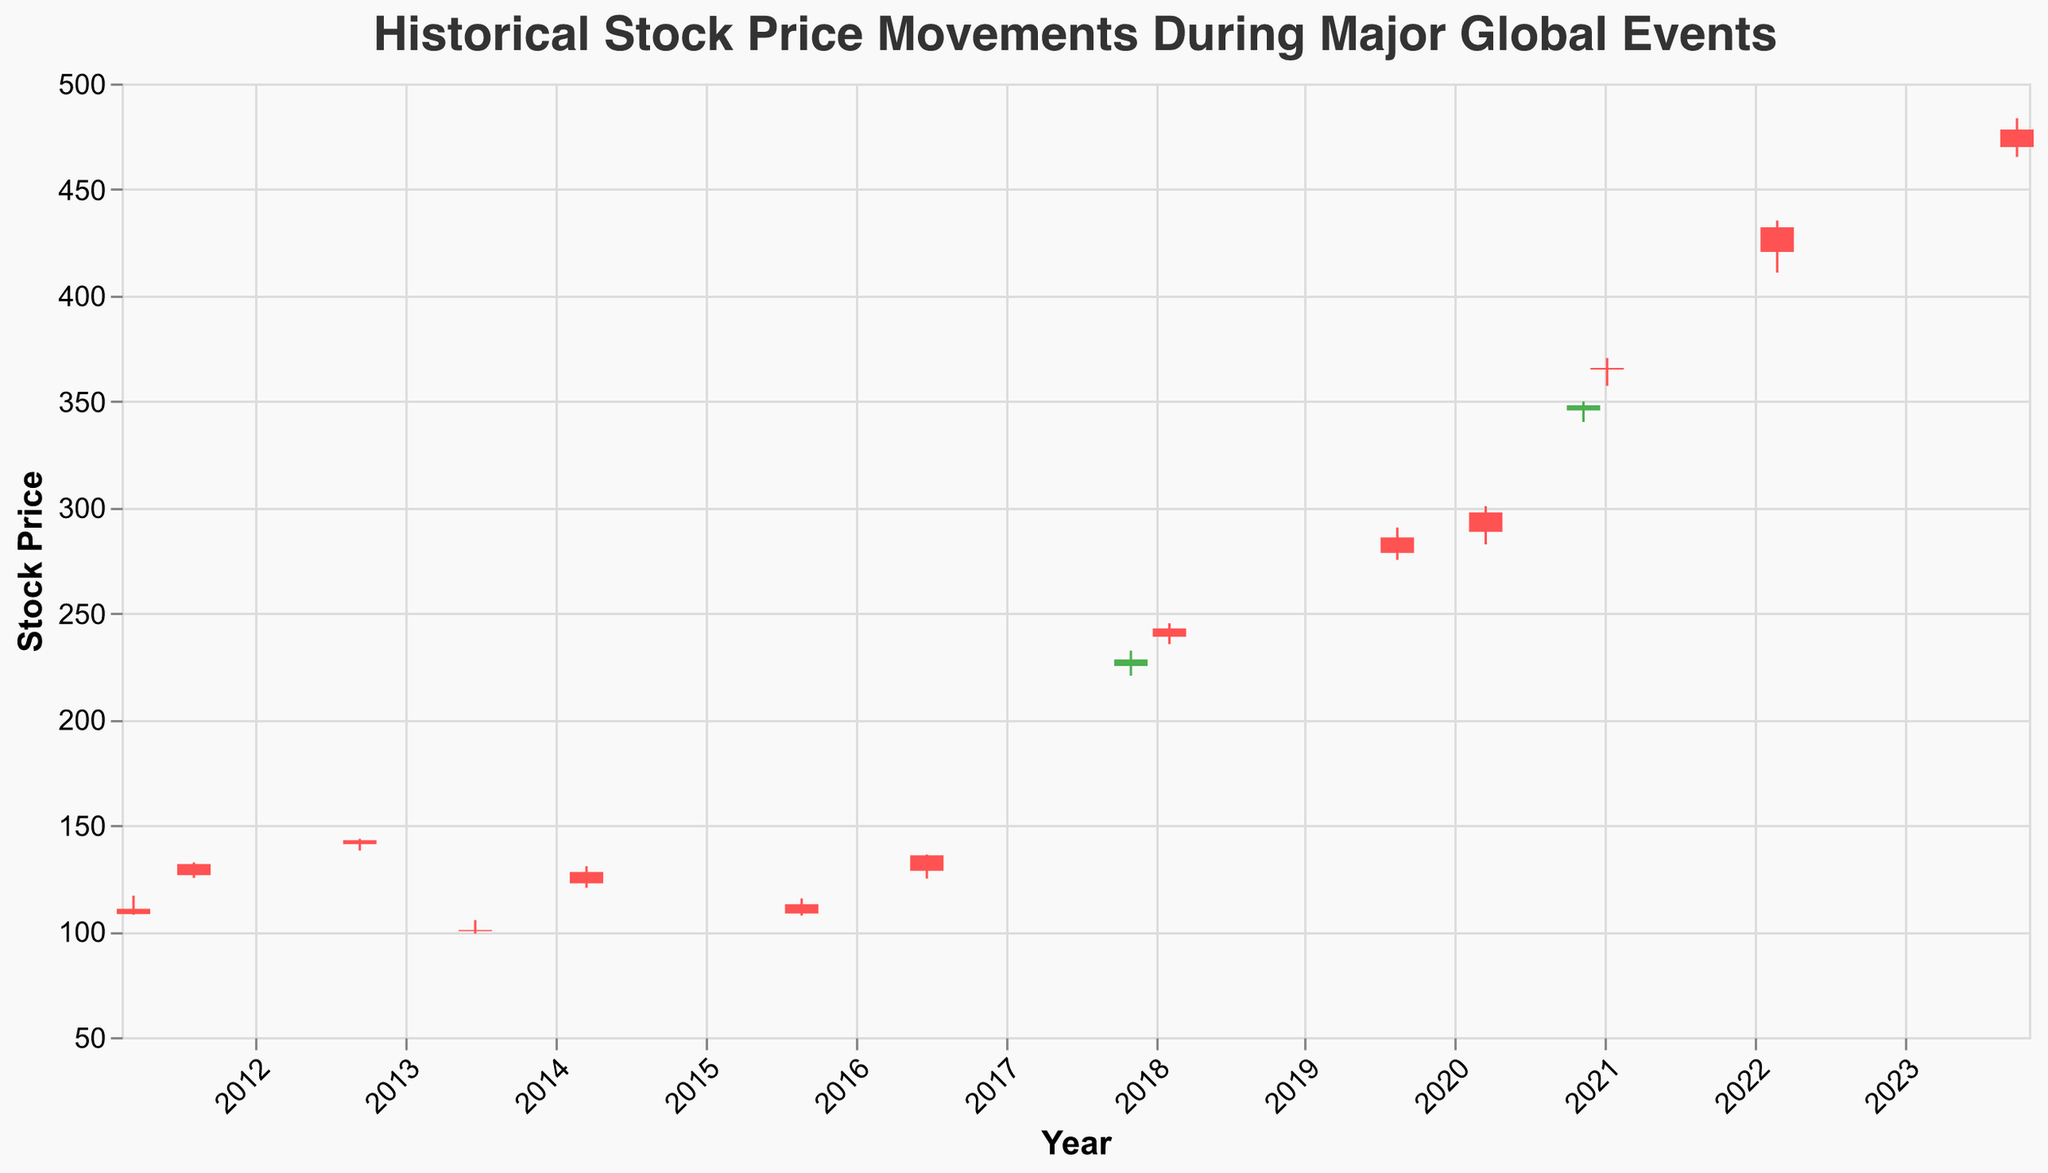Which event corresponds to the highest stock price close? Locate the highest closing stock price in the plot, which is $420.50 on 2022-02-24 during the Russian Invasion of Ukraine.
Answer: Russian Invasion of Ukraine What was the stock price range during the COVID-19 Pandemic Declared event? Identify the lowest and highest prices for this event: $282.50 (Low) and $300.52 (High).
Answer: $282.50 - $300.52 How much did the stock price change from open to close during the Brexit Referendum? Subtract the closing price ($128.45) from the opening price ($135.78).
Answer: -$7.33 Did the stock price close higher or lower than it opened during the US Debt Ceiling Crisis? Check if the closing price ($126.45) is greater than the opening price ($131.62).
Answer: Lower Which event had the highest trading volume? Identify the highest volume value in the plot, which is 8,000,000 during the COVID-19 Pandemic Declared event.
Answer: COVID-19 Pandemic Declared What's the average closing price of all the events? Sum all the closing prices and divide by the number of events. (108.02+126.45+141.00+99.99+122.53+108.30+128.45+228.20+238.89+278.50+288.45+348.10+365.00+420.50+470.02) / 15 = 226.75
Answer: 226.75 Compare the stock price change between the US Tax Reform and the 2018 Stock Market Correction events. Which had a larger drop? Calculate the difference for both events: US Tax Reform (225.15 to 228.20) and 2018 Stock Market Correction (242.85 to 238.89). The 2018 Stock Market Correction had a larger drop of -3.96 compared to the US Tax Reform’s +3.05.
Answer: 2018 Stock Market Correction What is the median closing stock price among the plotted events? Sort all closing prices and find the middle value. (99.99, 108.02, 108.30, 122.53, 126.45, 128.45, 141.00, 228.20, 238.89, 278.50, 288.45, 348.10, 365.00, 420.50, 470.02) The median value is 228.20.
Answer: 228.20 